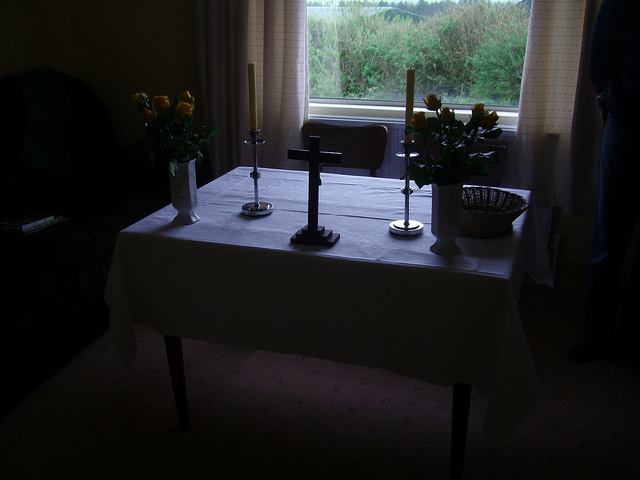<image>If the window in this picture is facing east, what time of day is it? It is uncertain what time of day it is just based on the direction of the window. If the window in this picture is facing east, what time of day is it? I don't know what time of day it is if the window in the picture is facing east. It can be in the afternoon, evening or morning. 